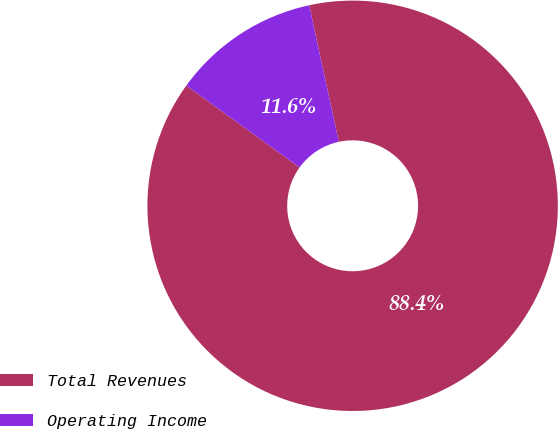Convert chart. <chart><loc_0><loc_0><loc_500><loc_500><pie_chart><fcel>Total Revenues<fcel>Operating Income<nl><fcel>88.36%<fcel>11.64%<nl></chart> 